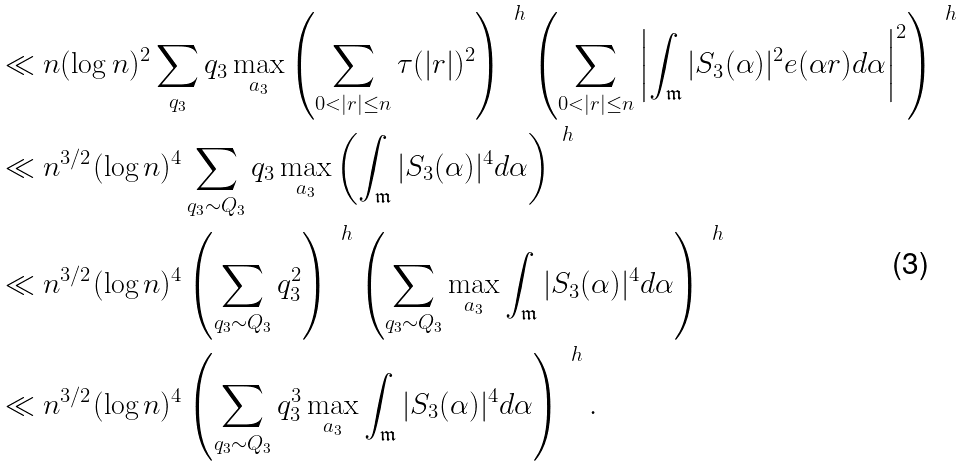<formula> <loc_0><loc_0><loc_500><loc_500>& \ll n ( \log n ) ^ { 2 } \sum _ { q _ { 3 } } q _ { 3 } \max _ { a _ { 3 } } \left ( \sum _ { 0 < | r | \leq n } \tau ( | r | ) ^ { 2 } \right ) ^ { \, \ h } \left ( \sum _ { 0 < | r | \leq n } \left | \int _ { \mathfrak { m } } | S _ { 3 } ( \alpha ) | ^ { 2 } e ( \alpha r ) d \alpha \right | ^ { 2 } \right ) ^ { \, \ h } \\ & \ll n ^ { 3 / 2 } ( \log n ) ^ { 4 } \sum _ { q _ { 3 } \sim Q _ { 3 } } q _ { 3 } \max _ { a _ { 3 } } \left ( \int _ { \mathfrak { m } } | S _ { 3 } ( \alpha ) | ^ { 4 } d \alpha \right ) ^ { \, \ h } \\ & \ll n ^ { 3 / 2 } ( \log n ) ^ { 4 } \left ( \sum _ { q _ { 3 } \sim Q _ { 3 } } q _ { 3 } ^ { 2 } \right ) ^ { \, \ h } \left ( \sum _ { q _ { 3 } \sim Q _ { 3 } } \max _ { a _ { 3 } } \int _ { \mathfrak { m } } | S _ { 3 } ( \alpha ) | ^ { 4 } d \alpha \right ) ^ { \, \ h } \\ & \ll n ^ { 3 / 2 } ( \log n ) ^ { 4 } \left ( \sum _ { q _ { 3 } \sim Q _ { 3 } } q _ { 3 } ^ { 3 } \max _ { a _ { 3 } } \int _ { \mathfrak { m } } | S _ { 3 } ( \alpha ) | ^ { 4 } d \alpha \right ) ^ { \, \ h } .</formula> 